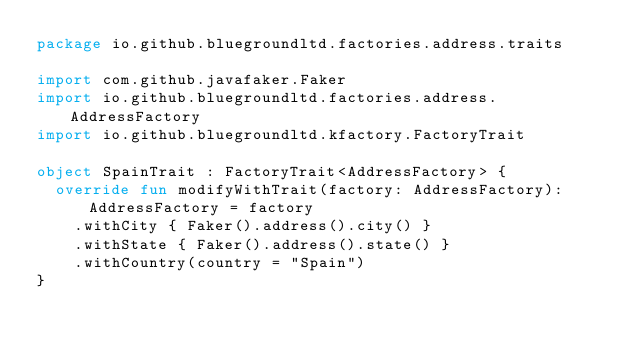Convert code to text. <code><loc_0><loc_0><loc_500><loc_500><_Kotlin_>package io.github.bluegroundltd.factories.address.traits

import com.github.javafaker.Faker
import io.github.bluegroundltd.factories.address.AddressFactory
import io.github.bluegroundltd.kfactory.FactoryTrait

object SpainTrait : FactoryTrait<AddressFactory> {
  override fun modifyWithTrait(factory: AddressFactory): AddressFactory = factory
    .withCity { Faker().address().city() }
    .withState { Faker().address().state() }
    .withCountry(country = "Spain")
}
</code> 